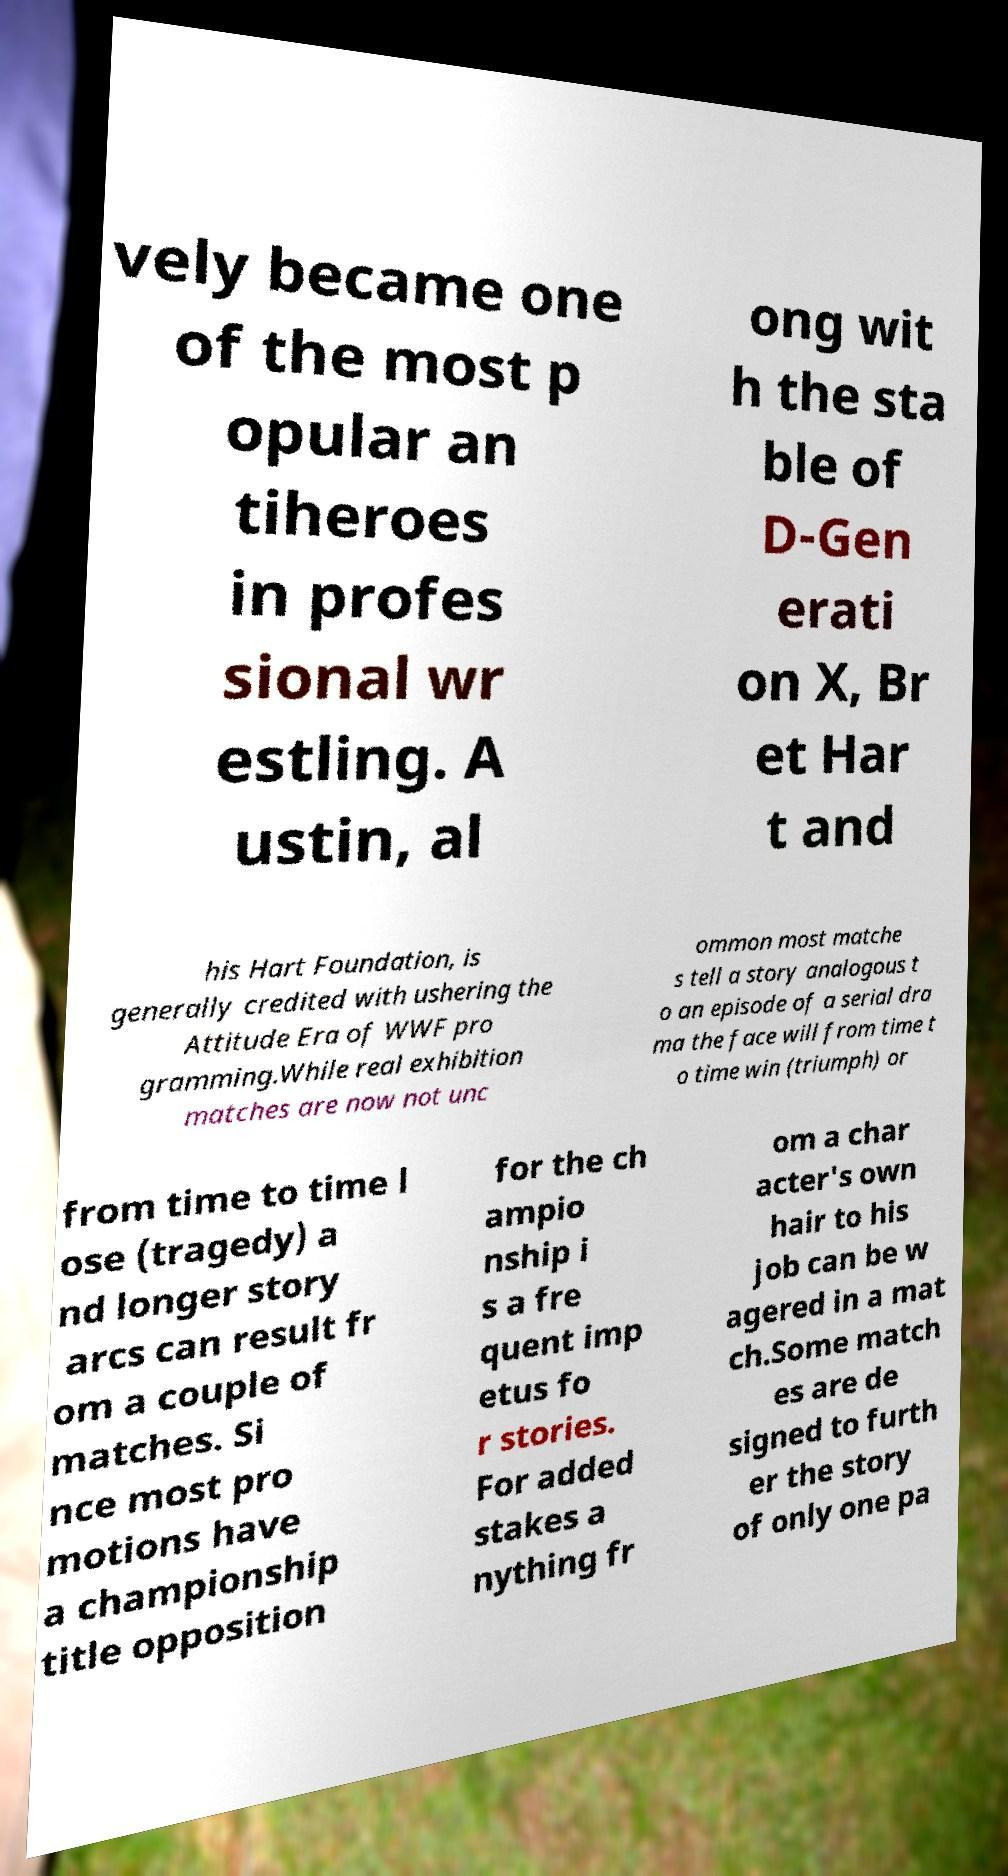Could you assist in decoding the text presented in this image and type it out clearly? vely became one of the most p opular an tiheroes in profes sional wr estling. A ustin, al ong wit h the sta ble of D-Gen erati on X, Br et Har t and his Hart Foundation, is generally credited with ushering the Attitude Era of WWF pro gramming.While real exhibition matches are now not unc ommon most matche s tell a story analogous t o an episode of a serial dra ma the face will from time t o time win (triumph) or from time to time l ose (tragedy) a nd longer story arcs can result fr om a couple of matches. Si nce most pro motions have a championship title opposition for the ch ampio nship i s a fre quent imp etus fo r stories. For added stakes a nything fr om a char acter's own hair to his job can be w agered in a mat ch.Some match es are de signed to furth er the story of only one pa 